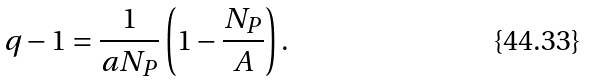Convert formula to latex. <formula><loc_0><loc_0><loc_500><loc_500>q - 1 = \frac { 1 } { a N _ { P } } \left ( 1 - \frac { N _ { P } } { A } \right ) .</formula> 